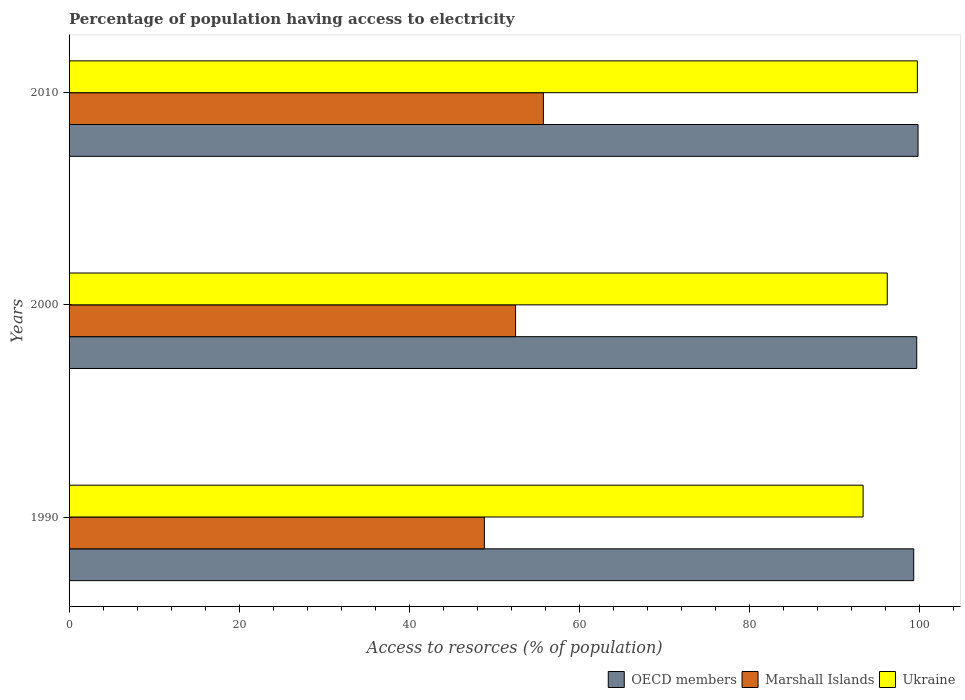How many groups of bars are there?
Your response must be concise. 3. Are the number of bars per tick equal to the number of legend labels?
Keep it short and to the point. Yes. How many bars are there on the 1st tick from the top?
Your answer should be very brief. 3. What is the label of the 3rd group of bars from the top?
Offer a very short reply. 1990. What is the percentage of population having access to electricity in Marshall Islands in 2000?
Offer a very short reply. 52.53. Across all years, what is the maximum percentage of population having access to electricity in Ukraine?
Offer a terse response. 99.8. Across all years, what is the minimum percentage of population having access to electricity in Marshall Islands?
Your answer should be very brief. 48.86. In which year was the percentage of population having access to electricity in Ukraine maximum?
Offer a very short reply. 2010. In which year was the percentage of population having access to electricity in Ukraine minimum?
Your answer should be very brief. 1990. What is the total percentage of population having access to electricity in OECD members in the graph?
Keep it short and to the point. 298.97. What is the difference between the percentage of population having access to electricity in Marshall Islands in 1990 and that in 2010?
Make the answer very short. -6.94. What is the difference between the percentage of population having access to electricity in Marshall Islands in 1990 and the percentage of population having access to electricity in Ukraine in 2010?
Your answer should be compact. -50.94. What is the average percentage of population having access to electricity in OECD members per year?
Provide a succinct answer. 99.66. In the year 2000, what is the difference between the percentage of population having access to electricity in OECD members and percentage of population having access to electricity in Marshall Islands?
Your answer should be very brief. 47.19. What is the ratio of the percentage of population having access to electricity in Ukraine in 1990 to that in 2000?
Your answer should be very brief. 0.97. Is the percentage of population having access to electricity in Marshall Islands in 1990 less than that in 2010?
Offer a terse response. Yes. Is the difference between the percentage of population having access to electricity in OECD members in 1990 and 2010 greater than the difference between the percentage of population having access to electricity in Marshall Islands in 1990 and 2010?
Ensure brevity in your answer.  Yes. What is the difference between the highest and the second highest percentage of population having access to electricity in Ukraine?
Provide a short and direct response. 3.54. What is the difference between the highest and the lowest percentage of population having access to electricity in Marshall Islands?
Offer a terse response. 6.94. Is the sum of the percentage of population having access to electricity in Ukraine in 2000 and 2010 greater than the maximum percentage of population having access to electricity in OECD members across all years?
Give a very brief answer. Yes. What does the 1st bar from the top in 2010 represents?
Ensure brevity in your answer.  Ukraine. What does the 2nd bar from the bottom in 2010 represents?
Your answer should be very brief. Marshall Islands. Is it the case that in every year, the sum of the percentage of population having access to electricity in Ukraine and percentage of population having access to electricity in Marshall Islands is greater than the percentage of population having access to electricity in OECD members?
Provide a succinct answer. Yes. How many bars are there?
Provide a short and direct response. 9. How many years are there in the graph?
Your response must be concise. 3. What is the difference between two consecutive major ticks on the X-axis?
Ensure brevity in your answer.  20. Does the graph contain any zero values?
Provide a succinct answer. No. Does the graph contain grids?
Provide a succinct answer. No. How many legend labels are there?
Give a very brief answer. 3. What is the title of the graph?
Offer a very short reply. Percentage of population having access to electricity. What is the label or title of the X-axis?
Your response must be concise. Access to resorces (% of population). What is the label or title of the Y-axis?
Your response must be concise. Years. What is the Access to resorces (% of population) in OECD members in 1990?
Ensure brevity in your answer.  99.37. What is the Access to resorces (% of population) in Marshall Islands in 1990?
Your answer should be compact. 48.86. What is the Access to resorces (% of population) of Ukraine in 1990?
Your answer should be very brief. 93.42. What is the Access to resorces (% of population) in OECD members in 2000?
Ensure brevity in your answer.  99.72. What is the Access to resorces (% of population) in Marshall Islands in 2000?
Make the answer very short. 52.53. What is the Access to resorces (% of population) of Ukraine in 2000?
Make the answer very short. 96.26. What is the Access to resorces (% of population) in OECD members in 2010?
Your answer should be compact. 99.88. What is the Access to resorces (% of population) of Marshall Islands in 2010?
Your answer should be compact. 55.8. What is the Access to resorces (% of population) in Ukraine in 2010?
Keep it short and to the point. 99.8. Across all years, what is the maximum Access to resorces (% of population) of OECD members?
Make the answer very short. 99.88. Across all years, what is the maximum Access to resorces (% of population) of Marshall Islands?
Your answer should be very brief. 55.8. Across all years, what is the maximum Access to resorces (% of population) in Ukraine?
Your answer should be very brief. 99.8. Across all years, what is the minimum Access to resorces (% of population) in OECD members?
Offer a terse response. 99.37. Across all years, what is the minimum Access to resorces (% of population) in Marshall Islands?
Make the answer very short. 48.86. Across all years, what is the minimum Access to resorces (% of population) of Ukraine?
Ensure brevity in your answer.  93.42. What is the total Access to resorces (% of population) of OECD members in the graph?
Ensure brevity in your answer.  298.97. What is the total Access to resorces (% of population) of Marshall Islands in the graph?
Give a very brief answer. 157.19. What is the total Access to resorces (% of population) of Ukraine in the graph?
Offer a terse response. 289.47. What is the difference between the Access to resorces (% of population) in OECD members in 1990 and that in 2000?
Your answer should be very brief. -0.35. What is the difference between the Access to resorces (% of population) in Marshall Islands in 1990 and that in 2000?
Your response must be concise. -3.67. What is the difference between the Access to resorces (% of population) of Ukraine in 1990 and that in 2000?
Your response must be concise. -2.84. What is the difference between the Access to resorces (% of population) in OECD members in 1990 and that in 2010?
Give a very brief answer. -0.51. What is the difference between the Access to resorces (% of population) of Marshall Islands in 1990 and that in 2010?
Provide a succinct answer. -6.94. What is the difference between the Access to resorces (% of population) in Ukraine in 1990 and that in 2010?
Provide a succinct answer. -6.38. What is the difference between the Access to resorces (% of population) in OECD members in 2000 and that in 2010?
Your answer should be compact. -0.15. What is the difference between the Access to resorces (% of population) of Marshall Islands in 2000 and that in 2010?
Your response must be concise. -3.27. What is the difference between the Access to resorces (% of population) in Ukraine in 2000 and that in 2010?
Provide a succinct answer. -3.54. What is the difference between the Access to resorces (% of population) in OECD members in 1990 and the Access to resorces (% of population) in Marshall Islands in 2000?
Your answer should be very brief. 46.84. What is the difference between the Access to resorces (% of population) in OECD members in 1990 and the Access to resorces (% of population) in Ukraine in 2000?
Your response must be concise. 3.11. What is the difference between the Access to resorces (% of population) of Marshall Islands in 1990 and the Access to resorces (% of population) of Ukraine in 2000?
Offer a very short reply. -47.4. What is the difference between the Access to resorces (% of population) of OECD members in 1990 and the Access to resorces (% of population) of Marshall Islands in 2010?
Offer a terse response. 43.57. What is the difference between the Access to resorces (% of population) in OECD members in 1990 and the Access to resorces (% of population) in Ukraine in 2010?
Keep it short and to the point. -0.43. What is the difference between the Access to resorces (% of population) in Marshall Islands in 1990 and the Access to resorces (% of population) in Ukraine in 2010?
Your answer should be very brief. -50.94. What is the difference between the Access to resorces (% of population) of OECD members in 2000 and the Access to resorces (% of population) of Marshall Islands in 2010?
Your answer should be compact. 43.92. What is the difference between the Access to resorces (% of population) of OECD members in 2000 and the Access to resorces (% of population) of Ukraine in 2010?
Provide a short and direct response. -0.08. What is the difference between the Access to resorces (% of population) of Marshall Islands in 2000 and the Access to resorces (% of population) of Ukraine in 2010?
Make the answer very short. -47.27. What is the average Access to resorces (% of population) in OECD members per year?
Your answer should be compact. 99.66. What is the average Access to resorces (% of population) in Marshall Islands per year?
Offer a very short reply. 52.4. What is the average Access to resorces (% of population) of Ukraine per year?
Provide a short and direct response. 96.49. In the year 1990, what is the difference between the Access to resorces (% of population) of OECD members and Access to resorces (% of population) of Marshall Islands?
Offer a very short reply. 50.51. In the year 1990, what is the difference between the Access to resorces (% of population) in OECD members and Access to resorces (% of population) in Ukraine?
Provide a short and direct response. 5.95. In the year 1990, what is the difference between the Access to resorces (% of population) in Marshall Islands and Access to resorces (% of population) in Ukraine?
Keep it short and to the point. -44.56. In the year 2000, what is the difference between the Access to resorces (% of population) in OECD members and Access to resorces (% of population) in Marshall Islands?
Make the answer very short. 47.19. In the year 2000, what is the difference between the Access to resorces (% of population) in OECD members and Access to resorces (% of population) in Ukraine?
Your answer should be very brief. 3.47. In the year 2000, what is the difference between the Access to resorces (% of population) in Marshall Islands and Access to resorces (% of population) in Ukraine?
Make the answer very short. -43.73. In the year 2010, what is the difference between the Access to resorces (% of population) in OECD members and Access to resorces (% of population) in Marshall Islands?
Provide a succinct answer. 44.08. In the year 2010, what is the difference between the Access to resorces (% of population) of OECD members and Access to resorces (% of population) of Ukraine?
Ensure brevity in your answer.  0.08. In the year 2010, what is the difference between the Access to resorces (% of population) of Marshall Islands and Access to resorces (% of population) of Ukraine?
Offer a terse response. -44. What is the ratio of the Access to resorces (% of population) in OECD members in 1990 to that in 2000?
Make the answer very short. 1. What is the ratio of the Access to resorces (% of population) in Marshall Islands in 1990 to that in 2000?
Offer a very short reply. 0.93. What is the ratio of the Access to resorces (% of population) in Ukraine in 1990 to that in 2000?
Your response must be concise. 0.97. What is the ratio of the Access to resorces (% of population) in Marshall Islands in 1990 to that in 2010?
Give a very brief answer. 0.88. What is the ratio of the Access to resorces (% of population) in Ukraine in 1990 to that in 2010?
Provide a succinct answer. 0.94. What is the ratio of the Access to resorces (% of population) of Marshall Islands in 2000 to that in 2010?
Ensure brevity in your answer.  0.94. What is the ratio of the Access to resorces (% of population) in Ukraine in 2000 to that in 2010?
Ensure brevity in your answer.  0.96. What is the difference between the highest and the second highest Access to resorces (% of population) of OECD members?
Ensure brevity in your answer.  0.15. What is the difference between the highest and the second highest Access to resorces (% of population) in Marshall Islands?
Your response must be concise. 3.27. What is the difference between the highest and the second highest Access to resorces (% of population) of Ukraine?
Give a very brief answer. 3.54. What is the difference between the highest and the lowest Access to resorces (% of population) of OECD members?
Provide a short and direct response. 0.51. What is the difference between the highest and the lowest Access to resorces (% of population) of Marshall Islands?
Offer a terse response. 6.94. What is the difference between the highest and the lowest Access to resorces (% of population) in Ukraine?
Offer a terse response. 6.38. 